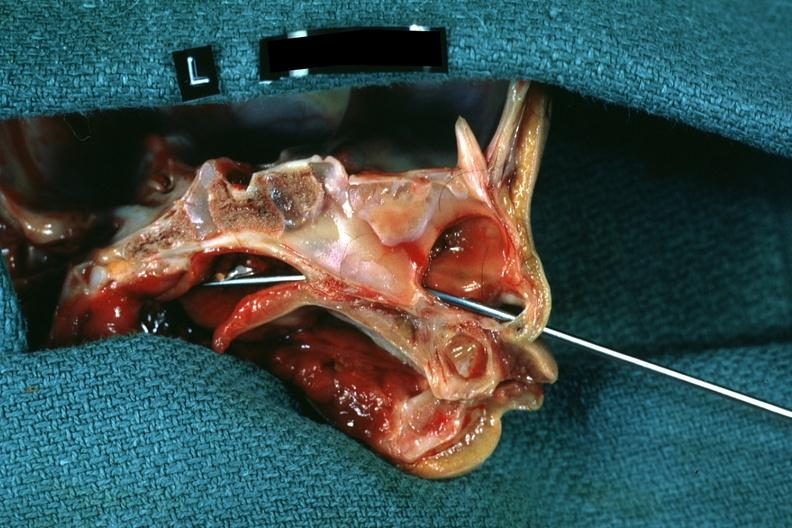s odontoid process subluxation with narrowing of foramen magnum left side showing patency right side was not patent?
Answer the question using a single word or phrase. No 